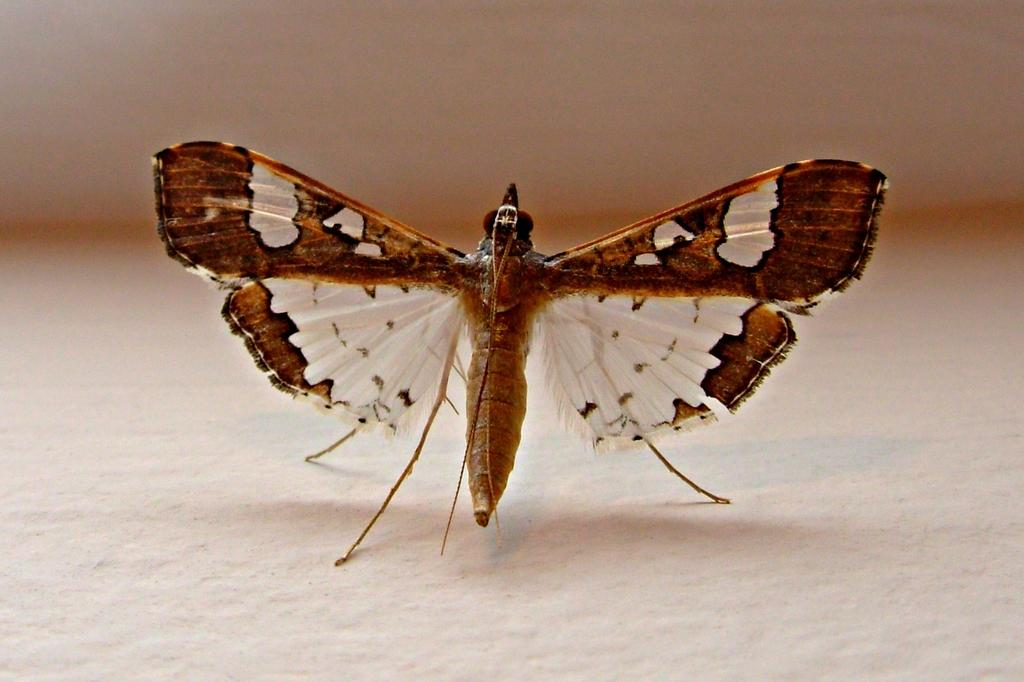What type of animal can be seen in the image? There is a butterfly in the image. Where is the butterfly located? The butterfly is on the surface. What type of juice is being served in the image? There is no juice present in the image; it features a butterfly on the surface. What is the nationality of the butterfly in the image? Butterflies do not have nationalities, as they are insects and not citizens of any nation. 